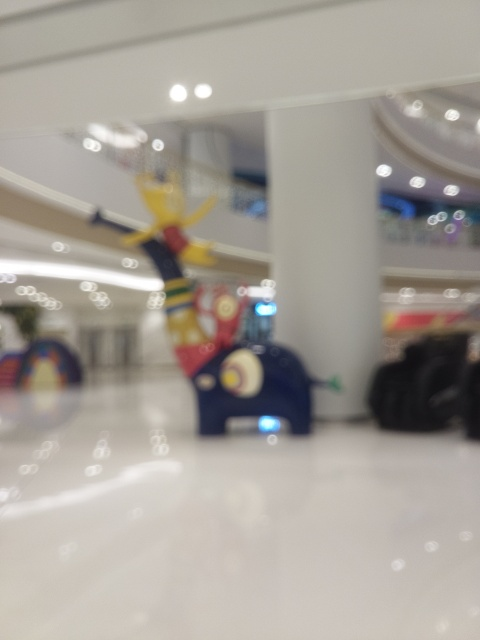Is the background distorted? Based on the image, the background appears to be slightly distorted, likely due to a shallow depth of field or lens blur, creating a soft focus effect. Specifically, the blur reduces the clarity of the surroundings and objects in the scene, which aren't the primary focus of the photograph. 